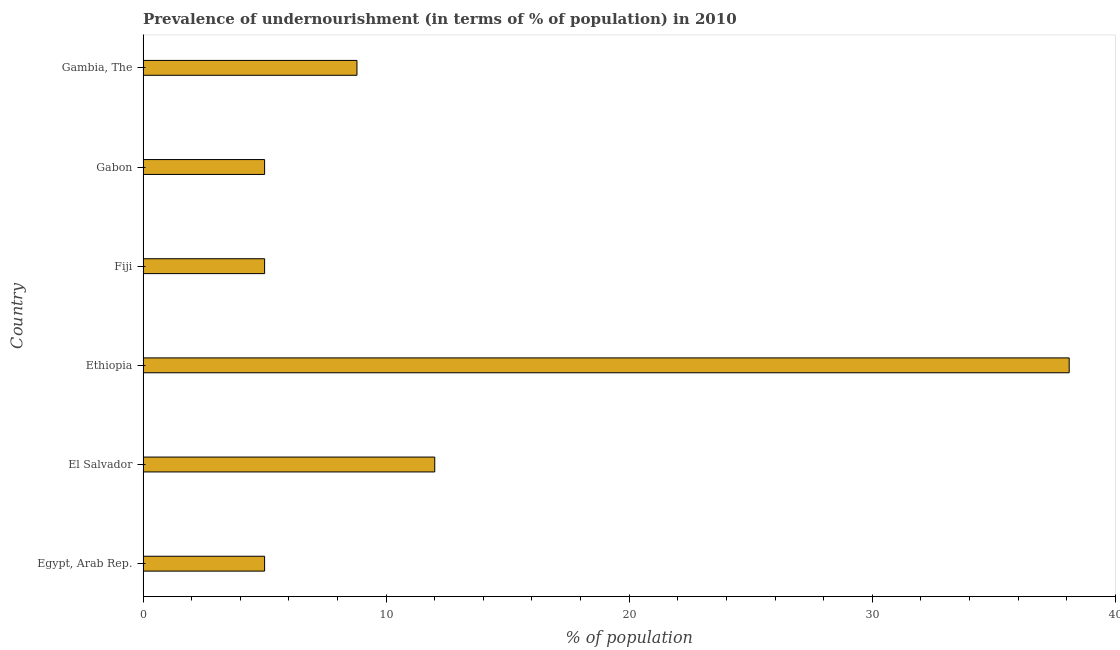Does the graph contain any zero values?
Provide a short and direct response. No. What is the title of the graph?
Make the answer very short. Prevalence of undernourishment (in terms of % of population) in 2010. What is the label or title of the X-axis?
Your response must be concise. % of population. What is the percentage of undernourished population in Fiji?
Keep it short and to the point. 5. Across all countries, what is the maximum percentage of undernourished population?
Your answer should be very brief. 38.1. Across all countries, what is the minimum percentage of undernourished population?
Keep it short and to the point. 5. In which country was the percentage of undernourished population maximum?
Make the answer very short. Ethiopia. In which country was the percentage of undernourished population minimum?
Offer a terse response. Egypt, Arab Rep. What is the sum of the percentage of undernourished population?
Offer a very short reply. 73.9. What is the difference between the percentage of undernourished population in Fiji and Gambia, The?
Offer a very short reply. -3.8. What is the average percentage of undernourished population per country?
Your answer should be very brief. 12.32. What is the ratio of the percentage of undernourished population in Egypt, Arab Rep. to that in Ethiopia?
Make the answer very short. 0.13. What is the difference between the highest and the second highest percentage of undernourished population?
Provide a short and direct response. 26.1. What is the difference between the highest and the lowest percentage of undernourished population?
Provide a succinct answer. 33.1. How many bars are there?
Make the answer very short. 6. How many countries are there in the graph?
Your response must be concise. 6. What is the % of population of Egypt, Arab Rep.?
Provide a short and direct response. 5. What is the % of population of Ethiopia?
Offer a very short reply. 38.1. What is the % of population in Gabon?
Offer a very short reply. 5. What is the % of population of Gambia, The?
Keep it short and to the point. 8.8. What is the difference between the % of population in Egypt, Arab Rep. and El Salvador?
Your answer should be compact. -7. What is the difference between the % of population in Egypt, Arab Rep. and Ethiopia?
Your response must be concise. -33.1. What is the difference between the % of population in Egypt, Arab Rep. and Gabon?
Keep it short and to the point. 0. What is the difference between the % of population in El Salvador and Ethiopia?
Ensure brevity in your answer.  -26.1. What is the difference between the % of population in El Salvador and Fiji?
Keep it short and to the point. 7. What is the difference between the % of population in El Salvador and Gabon?
Your answer should be compact. 7. What is the difference between the % of population in El Salvador and Gambia, The?
Your answer should be very brief. 3.2. What is the difference between the % of population in Ethiopia and Fiji?
Offer a terse response. 33.1. What is the difference between the % of population in Ethiopia and Gabon?
Offer a very short reply. 33.1. What is the difference between the % of population in Ethiopia and Gambia, The?
Make the answer very short. 29.3. What is the difference between the % of population in Fiji and Gabon?
Give a very brief answer. 0. What is the difference between the % of population in Fiji and Gambia, The?
Keep it short and to the point. -3.8. What is the difference between the % of population in Gabon and Gambia, The?
Keep it short and to the point. -3.8. What is the ratio of the % of population in Egypt, Arab Rep. to that in El Salvador?
Make the answer very short. 0.42. What is the ratio of the % of population in Egypt, Arab Rep. to that in Ethiopia?
Keep it short and to the point. 0.13. What is the ratio of the % of population in Egypt, Arab Rep. to that in Gambia, The?
Make the answer very short. 0.57. What is the ratio of the % of population in El Salvador to that in Ethiopia?
Your answer should be compact. 0.32. What is the ratio of the % of population in El Salvador to that in Gambia, The?
Ensure brevity in your answer.  1.36. What is the ratio of the % of population in Ethiopia to that in Fiji?
Offer a terse response. 7.62. What is the ratio of the % of population in Ethiopia to that in Gabon?
Provide a short and direct response. 7.62. What is the ratio of the % of population in Ethiopia to that in Gambia, The?
Give a very brief answer. 4.33. What is the ratio of the % of population in Fiji to that in Gabon?
Offer a very short reply. 1. What is the ratio of the % of population in Fiji to that in Gambia, The?
Provide a succinct answer. 0.57. What is the ratio of the % of population in Gabon to that in Gambia, The?
Offer a very short reply. 0.57. 